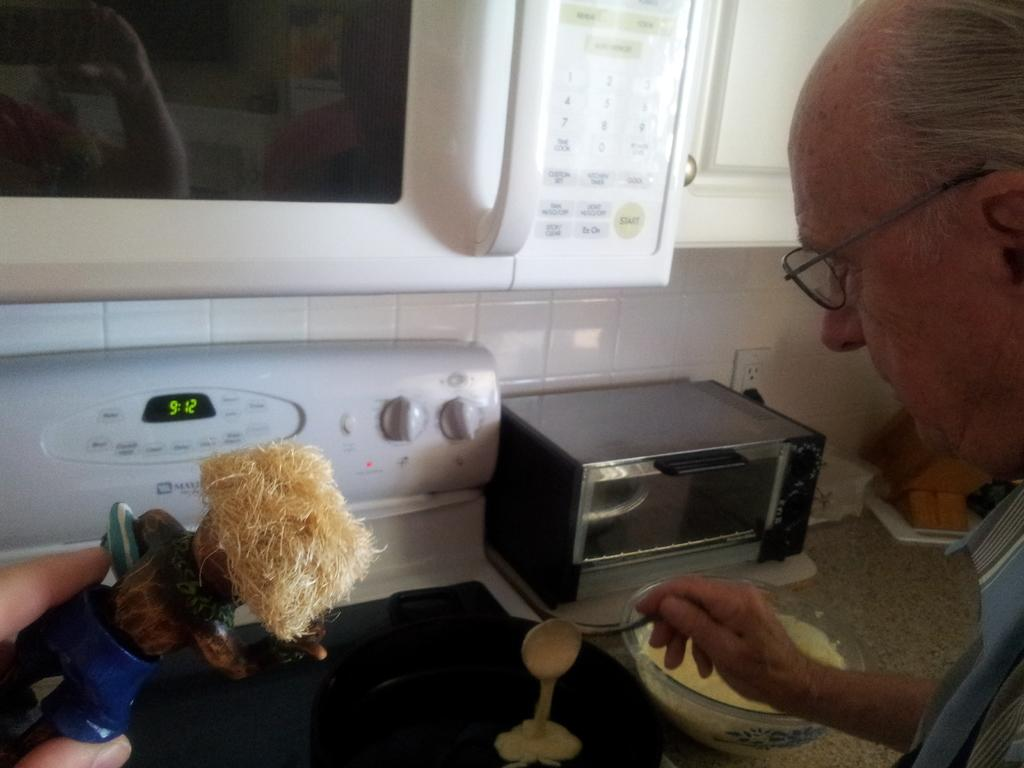<image>
Offer a succinct explanation of the picture presented. The time on the clock on the stove is 9:12. 